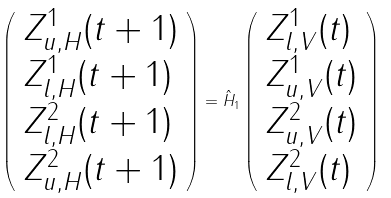Convert formula to latex. <formula><loc_0><loc_0><loc_500><loc_500>\left ( \begin{array} { l } Z _ { u , H } ^ { 1 } ( t + 1 ) \\ Z _ { l , H } ^ { 1 } ( t + 1 ) \\ Z _ { l , H } ^ { 2 } ( t + 1 ) \\ Z _ { u , H } ^ { 2 } ( t + 1 ) \end{array} \right ) = \hat { H } _ { 1 } \left ( \begin{array} { l } Z _ { l , V } ^ { 1 } ( t ) \\ Z _ { u , V } ^ { 1 } ( t ) \\ Z _ { u , V } ^ { 2 } ( t ) \\ Z _ { l , V } ^ { 2 } ( t ) \end{array} \right )</formula> 